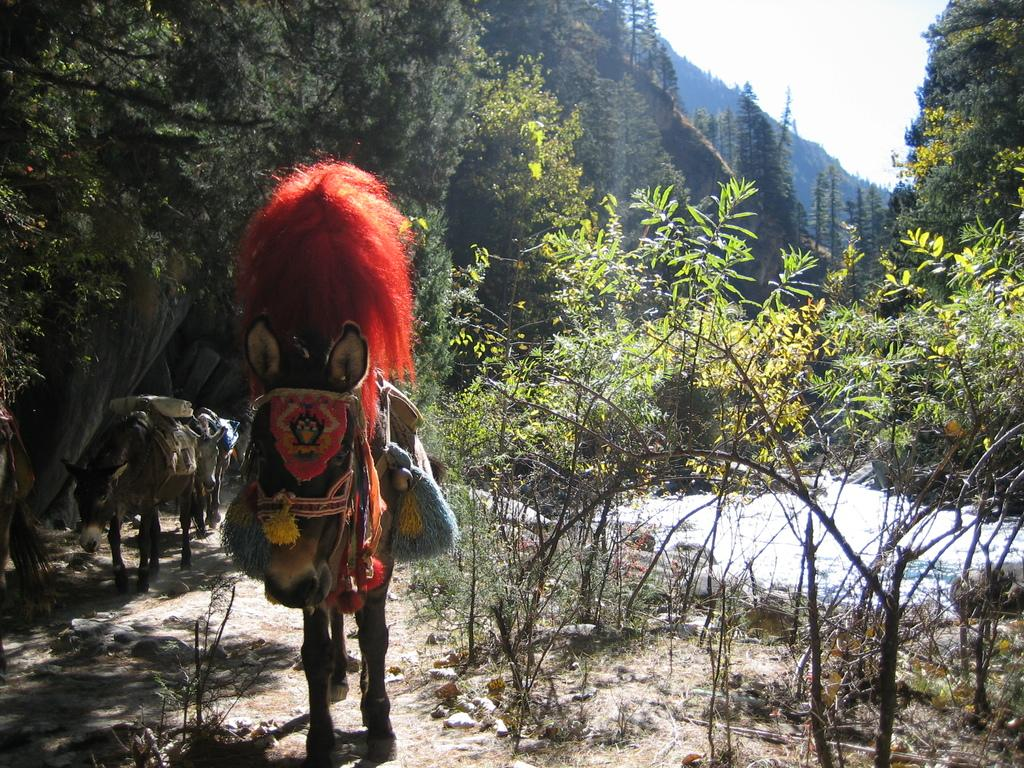What types of living organisms can be seen in the image? Animals and plants are visible in the image. What other natural elements can be seen in the image? Trees and water are visible in the image. What is visible in the background of the image? The sky is visible in the background of the image. What type of trade is being conducted in the image? There is no indication of any trade being conducted in the image. What is the frame made of that surrounds the image? The image does not have a frame, as it is a digital representation. 